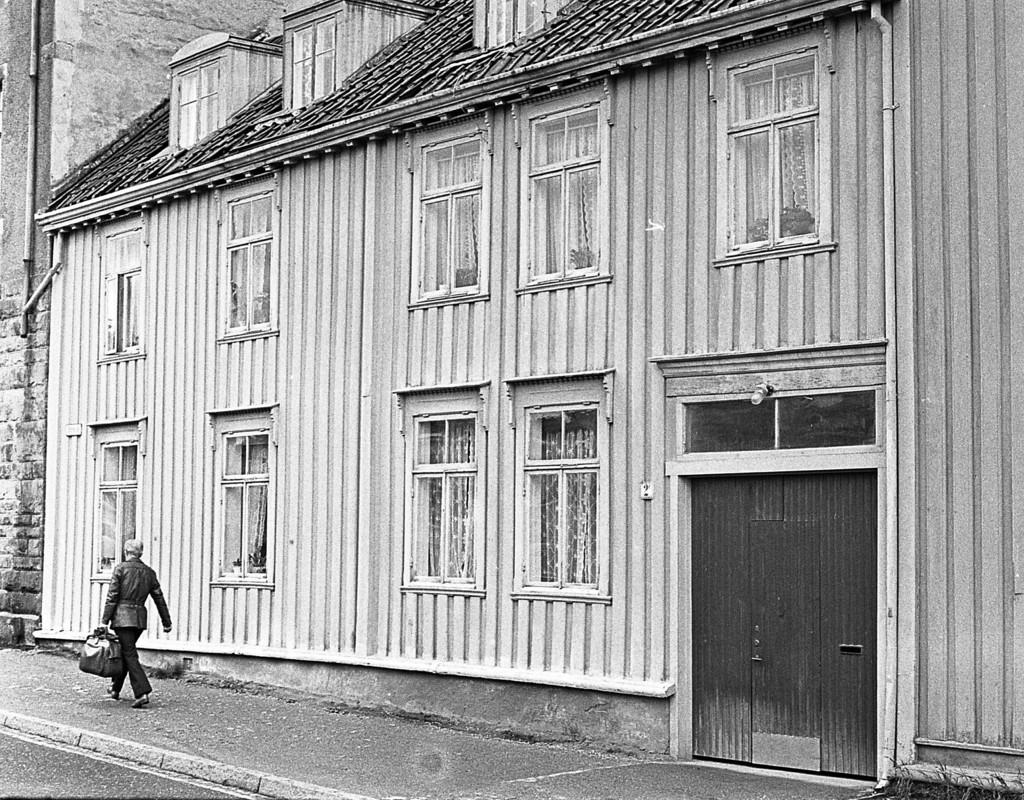What is the color scheme of the image? The image is black and white. What is the person in the image holding? The person is holding a bag in the image. What is the person doing in the image? The person is walking in the image. What can be seen in the background of the image? There is a building in the image, and it has windows. What type of jelly can be seen on the person's clothing in the image? There is no jelly visible on the person's clothing in the image. 